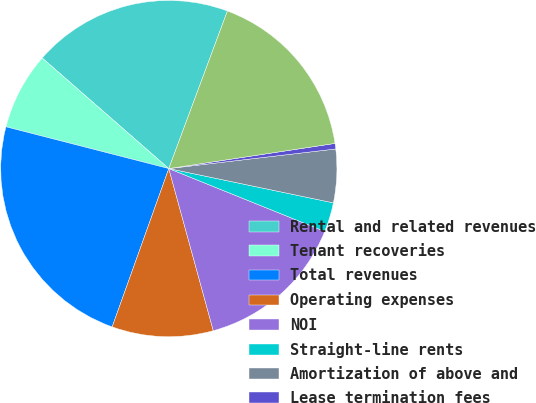<chart> <loc_0><loc_0><loc_500><loc_500><pie_chart><fcel>Rental and related revenues<fcel>Tenant recoveries<fcel>Total revenues<fcel>Operating expenses<fcel>NOI<fcel>Straight-line rents<fcel>Amortization of above and<fcel>Lease termination fees<fcel>Adjusted NOI<nl><fcel>19.24%<fcel>7.43%<fcel>23.53%<fcel>9.73%<fcel>14.64%<fcel>2.83%<fcel>5.13%<fcel>0.53%<fcel>16.94%<nl></chart> 